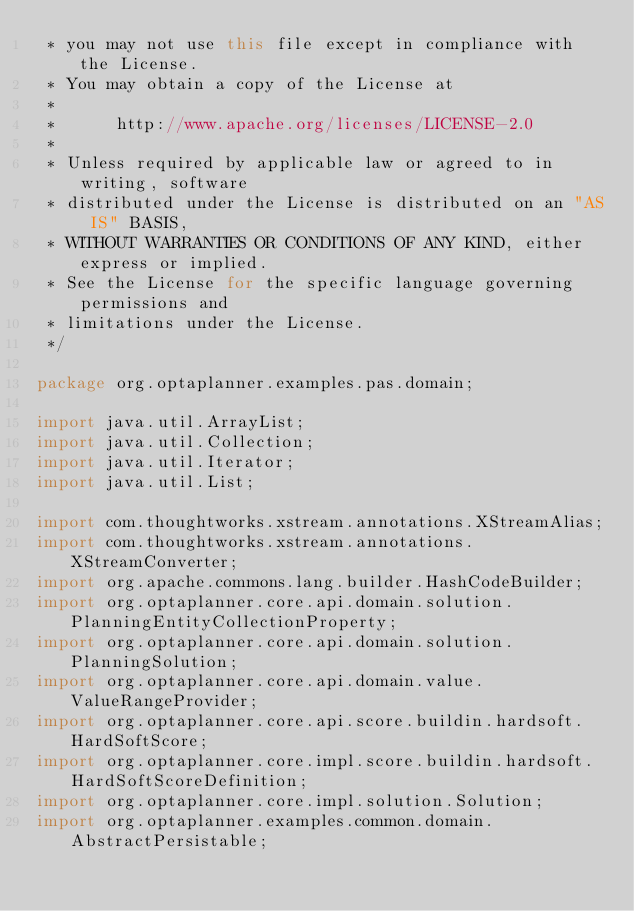<code> <loc_0><loc_0><loc_500><loc_500><_Java_> * you may not use this file except in compliance with the License.
 * You may obtain a copy of the License at
 *
 *      http://www.apache.org/licenses/LICENSE-2.0
 *
 * Unless required by applicable law or agreed to in writing, software
 * distributed under the License is distributed on an "AS IS" BASIS,
 * WITHOUT WARRANTIES OR CONDITIONS OF ANY KIND, either express or implied.
 * See the License for the specific language governing permissions and
 * limitations under the License.
 */

package org.optaplanner.examples.pas.domain;

import java.util.ArrayList;
import java.util.Collection;
import java.util.Iterator;
import java.util.List;

import com.thoughtworks.xstream.annotations.XStreamAlias;
import com.thoughtworks.xstream.annotations.XStreamConverter;
import org.apache.commons.lang.builder.HashCodeBuilder;
import org.optaplanner.core.api.domain.solution.PlanningEntityCollectionProperty;
import org.optaplanner.core.api.domain.solution.PlanningSolution;
import org.optaplanner.core.api.domain.value.ValueRangeProvider;
import org.optaplanner.core.api.score.buildin.hardsoft.HardSoftScore;
import org.optaplanner.core.impl.score.buildin.hardsoft.HardSoftScoreDefinition;
import org.optaplanner.core.impl.solution.Solution;
import org.optaplanner.examples.common.domain.AbstractPersistable;</code> 